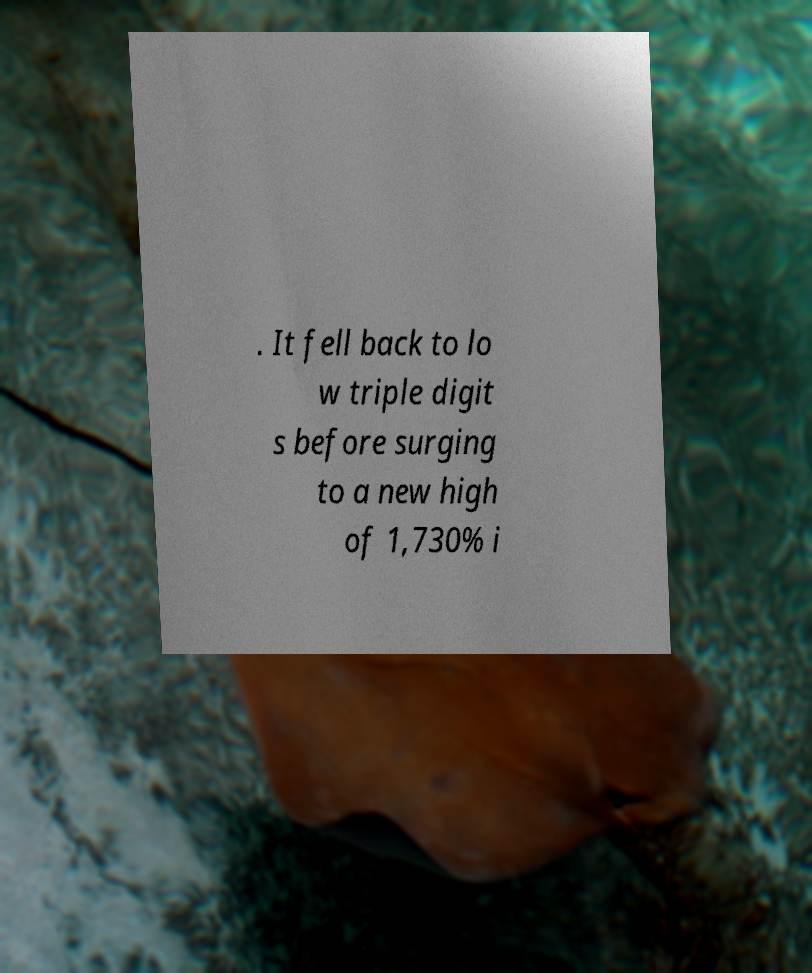What messages or text are displayed in this image? I need them in a readable, typed format. . It fell back to lo w triple digit s before surging to a new high of 1,730% i 